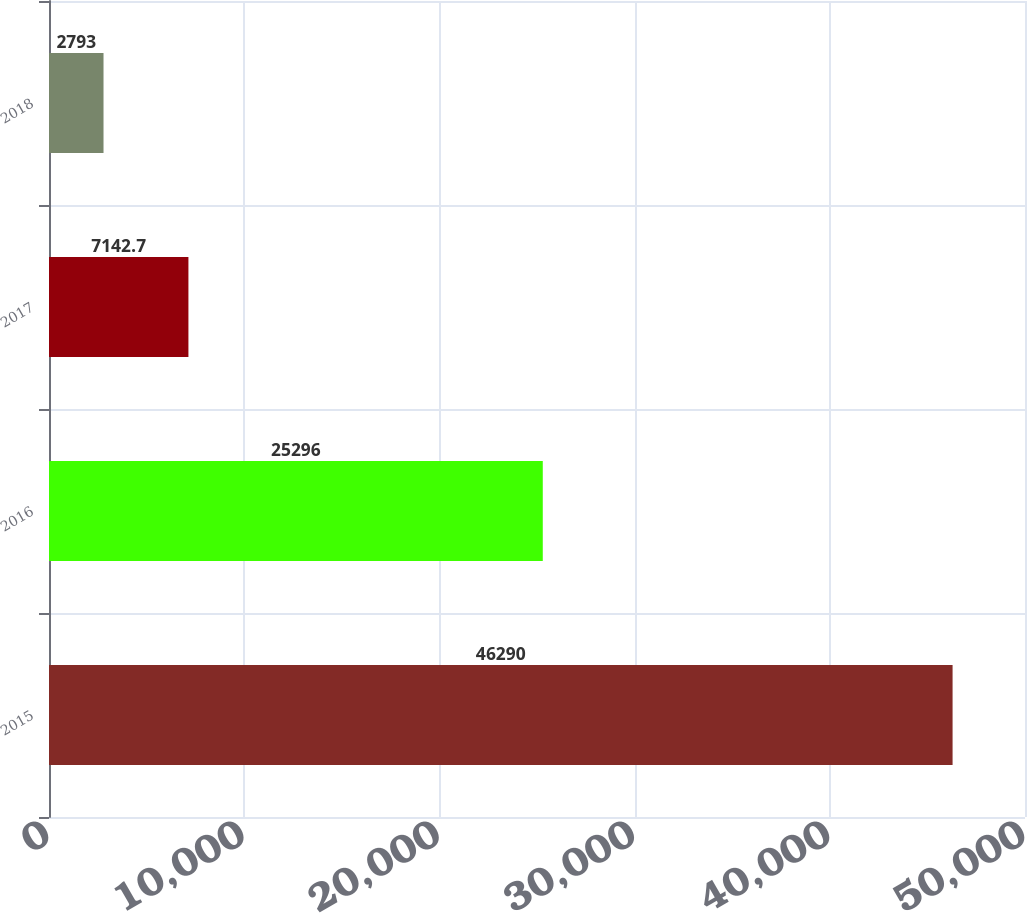<chart> <loc_0><loc_0><loc_500><loc_500><bar_chart><fcel>2015<fcel>2016<fcel>2017<fcel>2018<nl><fcel>46290<fcel>25296<fcel>7142.7<fcel>2793<nl></chart> 